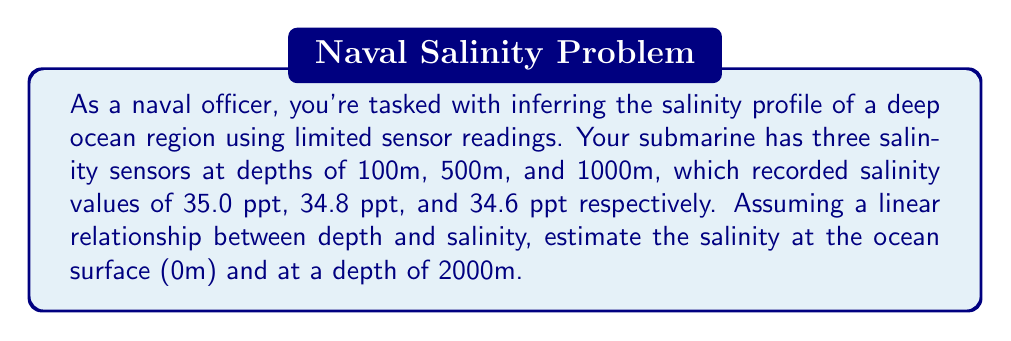Give your solution to this math problem. To solve this inverse problem, we'll use linear interpolation and extrapolation based on the given data points. Let's approach this step-by-step:

1) First, we need to establish the linear relationship between depth (x) and salinity (y):

   $y = mx + b$

   where m is the slope and b is the y-intercept (surface salinity in this case).

2) We can calculate the slope using any two points. Let's use the first and last points:

   $m = \frac{y_2 - y_1}{x_2 - x_1} = \frac{34.6 - 35.0}{1000 - 100} = -\frac{0.4}{900} = -\frac{4}{9000} \approx -0.000444$

3) Now that we have the slope, we can use any point to find b. Let's use the first point (100m, 35.0 ppt):

   $35.0 = -0.000444 * 100 + b$
   $b = 35.0 + 0.0444 = 35.0444$

4) Our linear equation is thus:

   $y = -0.000444x + 35.0444$

5) To find the surface salinity (0m):

   $y = -0.000444 * 0 + 35.0444 = 35.0444$ ppt

6) To find the salinity at 2000m:

   $y = -0.000444 * 2000 + 35.0444 = 34.1556$ ppt

Therefore, the estimated salinity at the surface is 35.0444 ppt and at 2000m depth is 34.1556 ppt.
Answer: Surface (0m): 35.0444 ppt; 2000m depth: 34.1556 ppt 